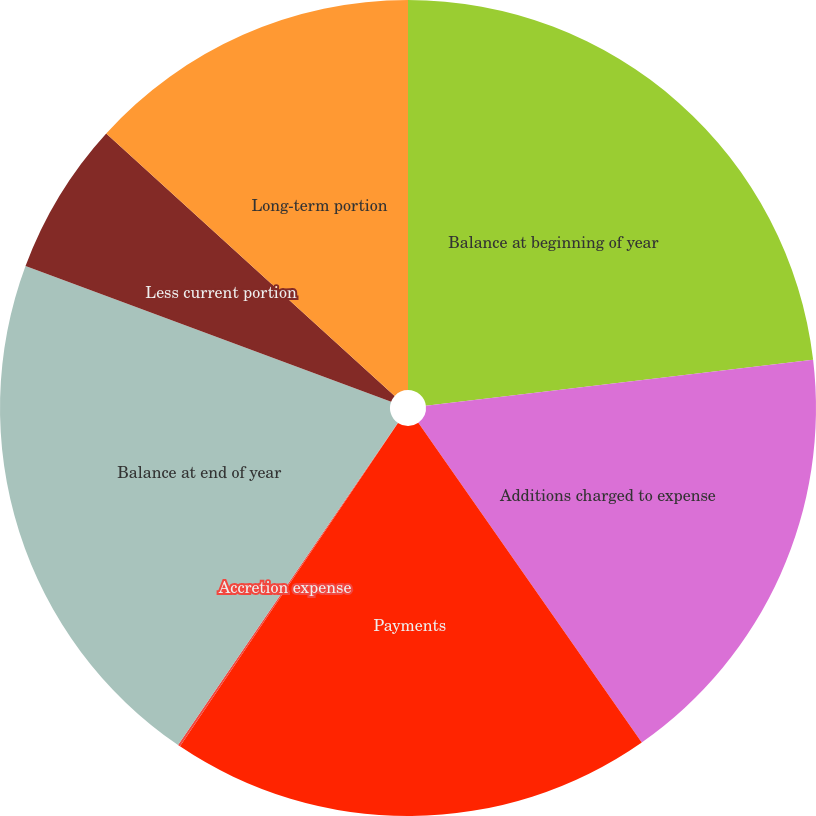Convert chart. <chart><loc_0><loc_0><loc_500><loc_500><pie_chart><fcel>Balance at beginning of year<fcel>Additions charged to expense<fcel>Payments<fcel>Accretion expense<fcel>Balance at end of year<fcel>Less current portion<fcel>Long-term portion<nl><fcel>23.11%<fcel>17.18%<fcel>19.15%<fcel>0.09%<fcel>21.13%<fcel>6.09%<fcel>13.25%<nl></chart> 